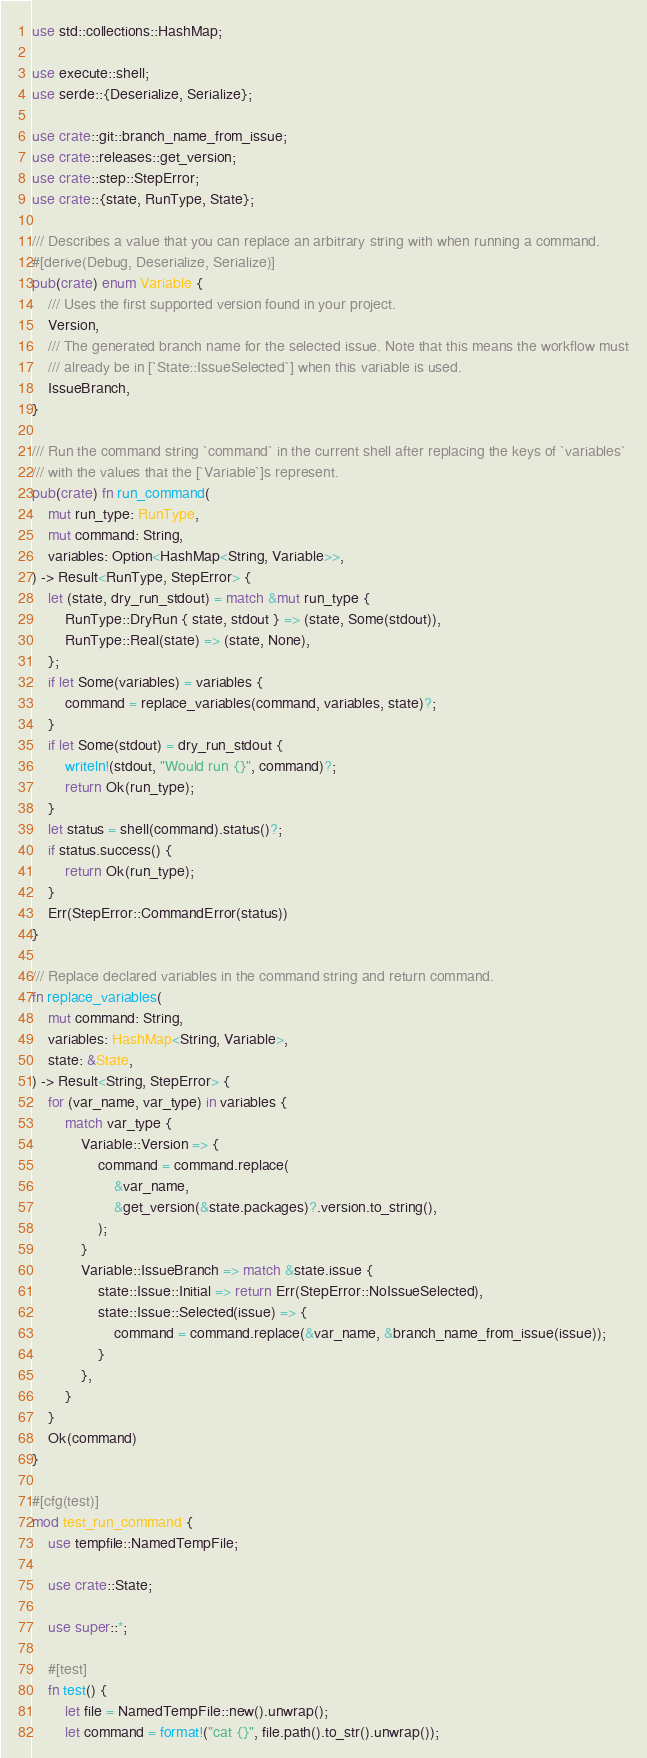Convert code to text. <code><loc_0><loc_0><loc_500><loc_500><_Rust_>use std::collections::HashMap;

use execute::shell;
use serde::{Deserialize, Serialize};

use crate::git::branch_name_from_issue;
use crate::releases::get_version;
use crate::step::StepError;
use crate::{state, RunType, State};

/// Describes a value that you can replace an arbitrary string with when running a command.
#[derive(Debug, Deserialize, Serialize)]
pub(crate) enum Variable {
    /// Uses the first supported version found in your project.
    Version,
    /// The generated branch name for the selected issue. Note that this means the workflow must
    /// already be in [`State::IssueSelected`] when this variable is used.
    IssueBranch,
}

/// Run the command string `command` in the current shell after replacing the keys of `variables`
/// with the values that the [`Variable`]s represent.
pub(crate) fn run_command(
    mut run_type: RunType,
    mut command: String,
    variables: Option<HashMap<String, Variable>>,
) -> Result<RunType, StepError> {
    let (state, dry_run_stdout) = match &mut run_type {
        RunType::DryRun { state, stdout } => (state, Some(stdout)),
        RunType::Real(state) => (state, None),
    };
    if let Some(variables) = variables {
        command = replace_variables(command, variables, state)?;
    }
    if let Some(stdout) = dry_run_stdout {
        writeln!(stdout, "Would run {}", command)?;
        return Ok(run_type);
    }
    let status = shell(command).status()?;
    if status.success() {
        return Ok(run_type);
    }
    Err(StepError::CommandError(status))
}

/// Replace declared variables in the command string and return command.
fn replace_variables(
    mut command: String,
    variables: HashMap<String, Variable>,
    state: &State,
) -> Result<String, StepError> {
    for (var_name, var_type) in variables {
        match var_type {
            Variable::Version => {
                command = command.replace(
                    &var_name,
                    &get_version(&state.packages)?.version.to_string(),
                );
            }
            Variable::IssueBranch => match &state.issue {
                state::Issue::Initial => return Err(StepError::NoIssueSelected),
                state::Issue::Selected(issue) => {
                    command = command.replace(&var_name, &branch_name_from_issue(issue));
                }
            },
        }
    }
    Ok(command)
}

#[cfg(test)]
mod test_run_command {
    use tempfile::NamedTempFile;

    use crate::State;

    use super::*;

    #[test]
    fn test() {
        let file = NamedTempFile::new().unwrap();
        let command = format!("cat {}", file.path().to_str().unwrap());</code> 